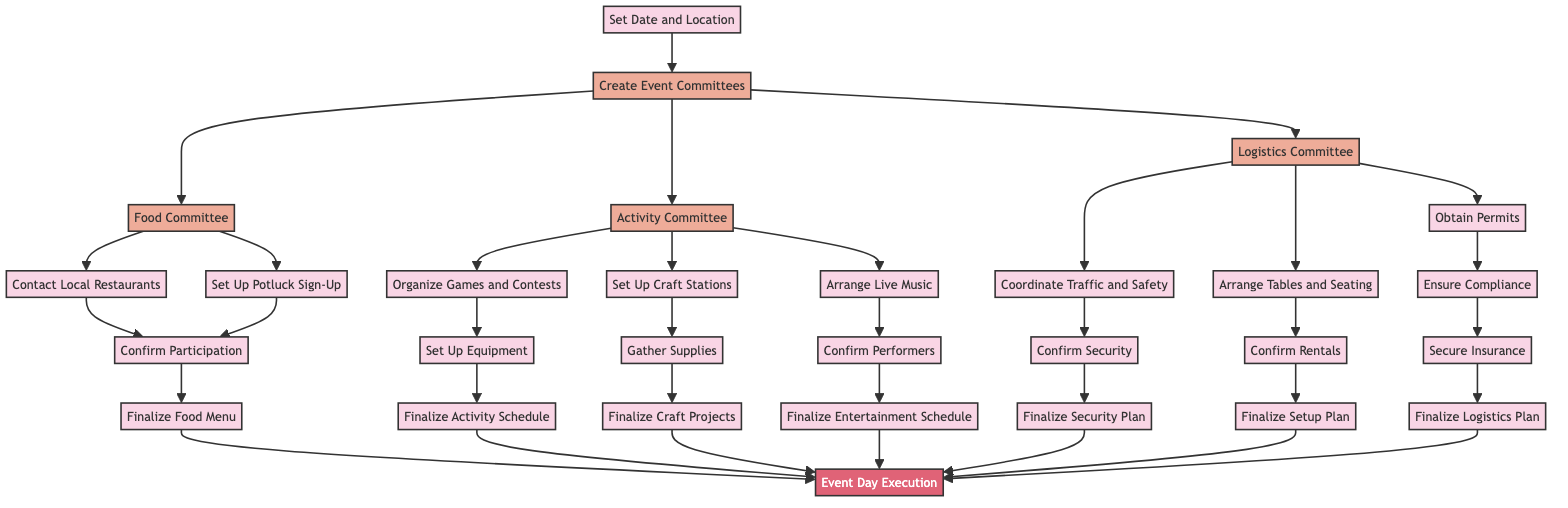What is the first step in organizing the block party? The first step outlined in the flow chart is to "Set Date and Location." This initiates the process of organizing the block party.
Answer: Set Date and Location How many committees are created after the initial step? Following the "Create Event Committees" step, three committees are formed: Food Committee, Activity Committee, and Logistics Committee. This is evident as they directly branch from the event committees node.
Answer: Three What follows after confirming participation in food arrangements? After confirming participation in food arrangements, the next step is to "Finalize Food Menu." This is a direct continuation from the confirmation of participation node related to food.
Answer: Finalize Food Menu Which committee is responsible for organizing activities? The "Activity Committee" is designated for planning family-friendly activities, as it is specifically outlined in the diagram under the event committees.
Answer: Activity Committee How does the flow for logistics operations progress? The Logistics Committee will proceed by obtaining permits, coordinating traffic and safety, and arranging tables and seating. After tackling these tasks in sequence, they reach either security confirmation or setup plan finalization. Each task in logistics leads to a subsequent action, facilitating proper planning.
Answer: Obtain Permits, Coordinate Traffic and Safety, Arrange Tables and Seating Which activities are planned under the "Activity Committee"? The "Activity Committee" plans for games and contests, craft stations, and live music arrangements. All activities branch directly under this committee in the diagram.
Answer: Games and Contests, Craft Stations, Live Music What is the last step in the event planning process? The final step in the flow chart for the event planning is "Event Day Execution," where all planned activities and arrangements are carried out to ensure a successful block party. This step captures the culmination of all previous efforts.
Answer: Event Day Execution How many finalization tasks lead to the Event Day Execution? There are six finalization tasks leading to "Event Day Execution": Finalize Food Menu, Finalize Activity Schedule, Finalize Craft Projects, Finalize Entertainment Schedule, Finalize Security Plan, and Finalize Setup Plan. All these tasks culminate in the execution of the event.
Answer: Six What action is necessary after ensuring compliance with permits? Once compliance is ensured, the next action required is to "Secure Insurance." This follows logically to ensure all necessary legal and safety protections are in place.
Answer: Secure Insurance 